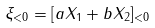<formula> <loc_0><loc_0><loc_500><loc_500>\xi _ { < 0 } = [ a X _ { 1 } + b X _ { 2 } ] _ { < 0 }</formula> 